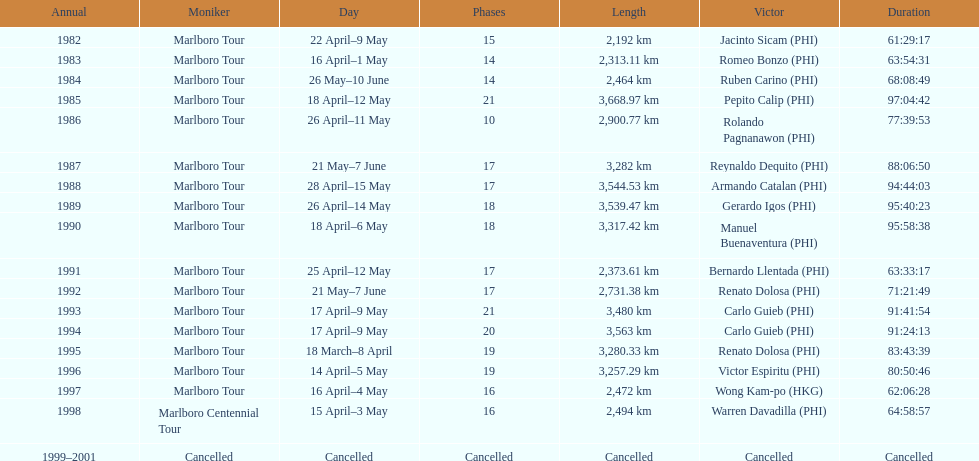How long did it take warren davadilla to complete the 1998 marlboro centennial tour? 64:58:57. 